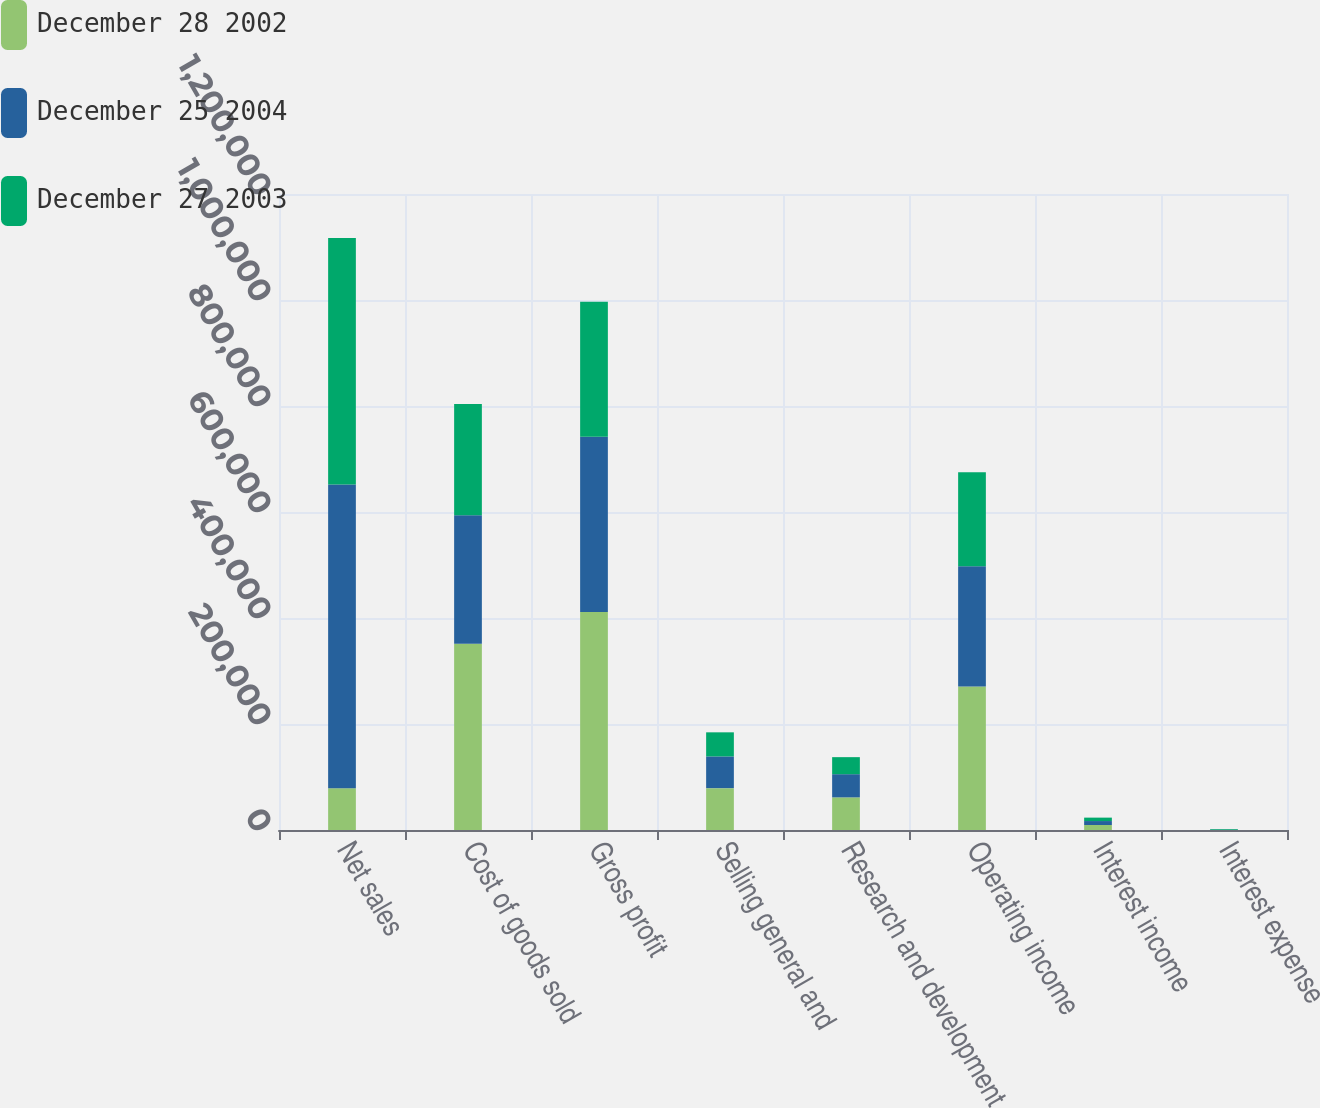<chart> <loc_0><loc_0><loc_500><loc_500><stacked_bar_chart><ecel><fcel>Net sales<fcel>Cost of goods sold<fcel>Gross profit<fcel>Selling general and<fcel>Research and development<fcel>Operating income<fcel>Interest income<fcel>Interest expense<nl><fcel>December 28 2002<fcel>78991<fcel>351310<fcel>411239<fcel>78991<fcel>61580<fcel>270668<fcel>9419<fcel>38<nl><fcel>December 25 2004<fcel>572989<fcel>242448<fcel>330541<fcel>59835<fcel>43706<fcel>227000<fcel>7473<fcel>534<nl><fcel>December 27 2003<fcel>465144<fcel>210088<fcel>255056<fcel>45453<fcel>32163<fcel>177440<fcel>6466<fcel>1329<nl></chart> 